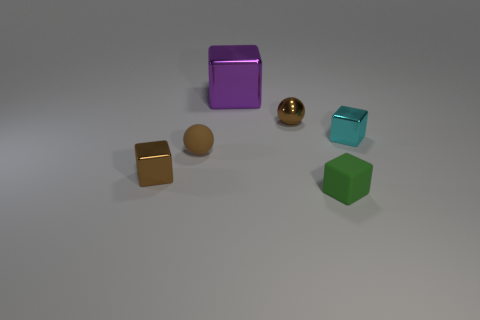Add 1 big metal cubes. How many objects exist? 7 Subtract all cyan metal cubes. How many cubes are left? 3 Subtract all spheres. How many objects are left? 4 Add 1 matte balls. How many matte balls exist? 2 Subtract all green blocks. How many blocks are left? 3 Subtract 0 green balls. How many objects are left? 6 Subtract 1 balls. How many balls are left? 1 Subtract all gray balls. Subtract all yellow cubes. How many balls are left? 2 Subtract all brown balls. How many red cubes are left? 0 Subtract all cyan shiny blocks. Subtract all matte balls. How many objects are left? 4 